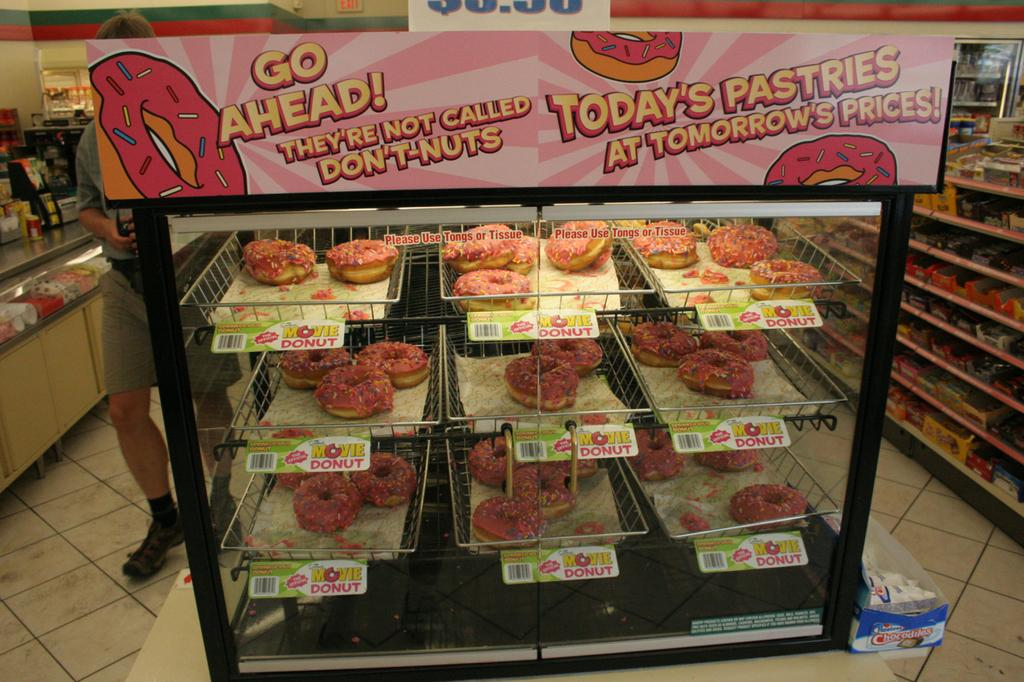<image>
Create a compact narrative representing the image presented. A brand of doughnuts called "Movie" are setting on the racks inside of a cabinet. 